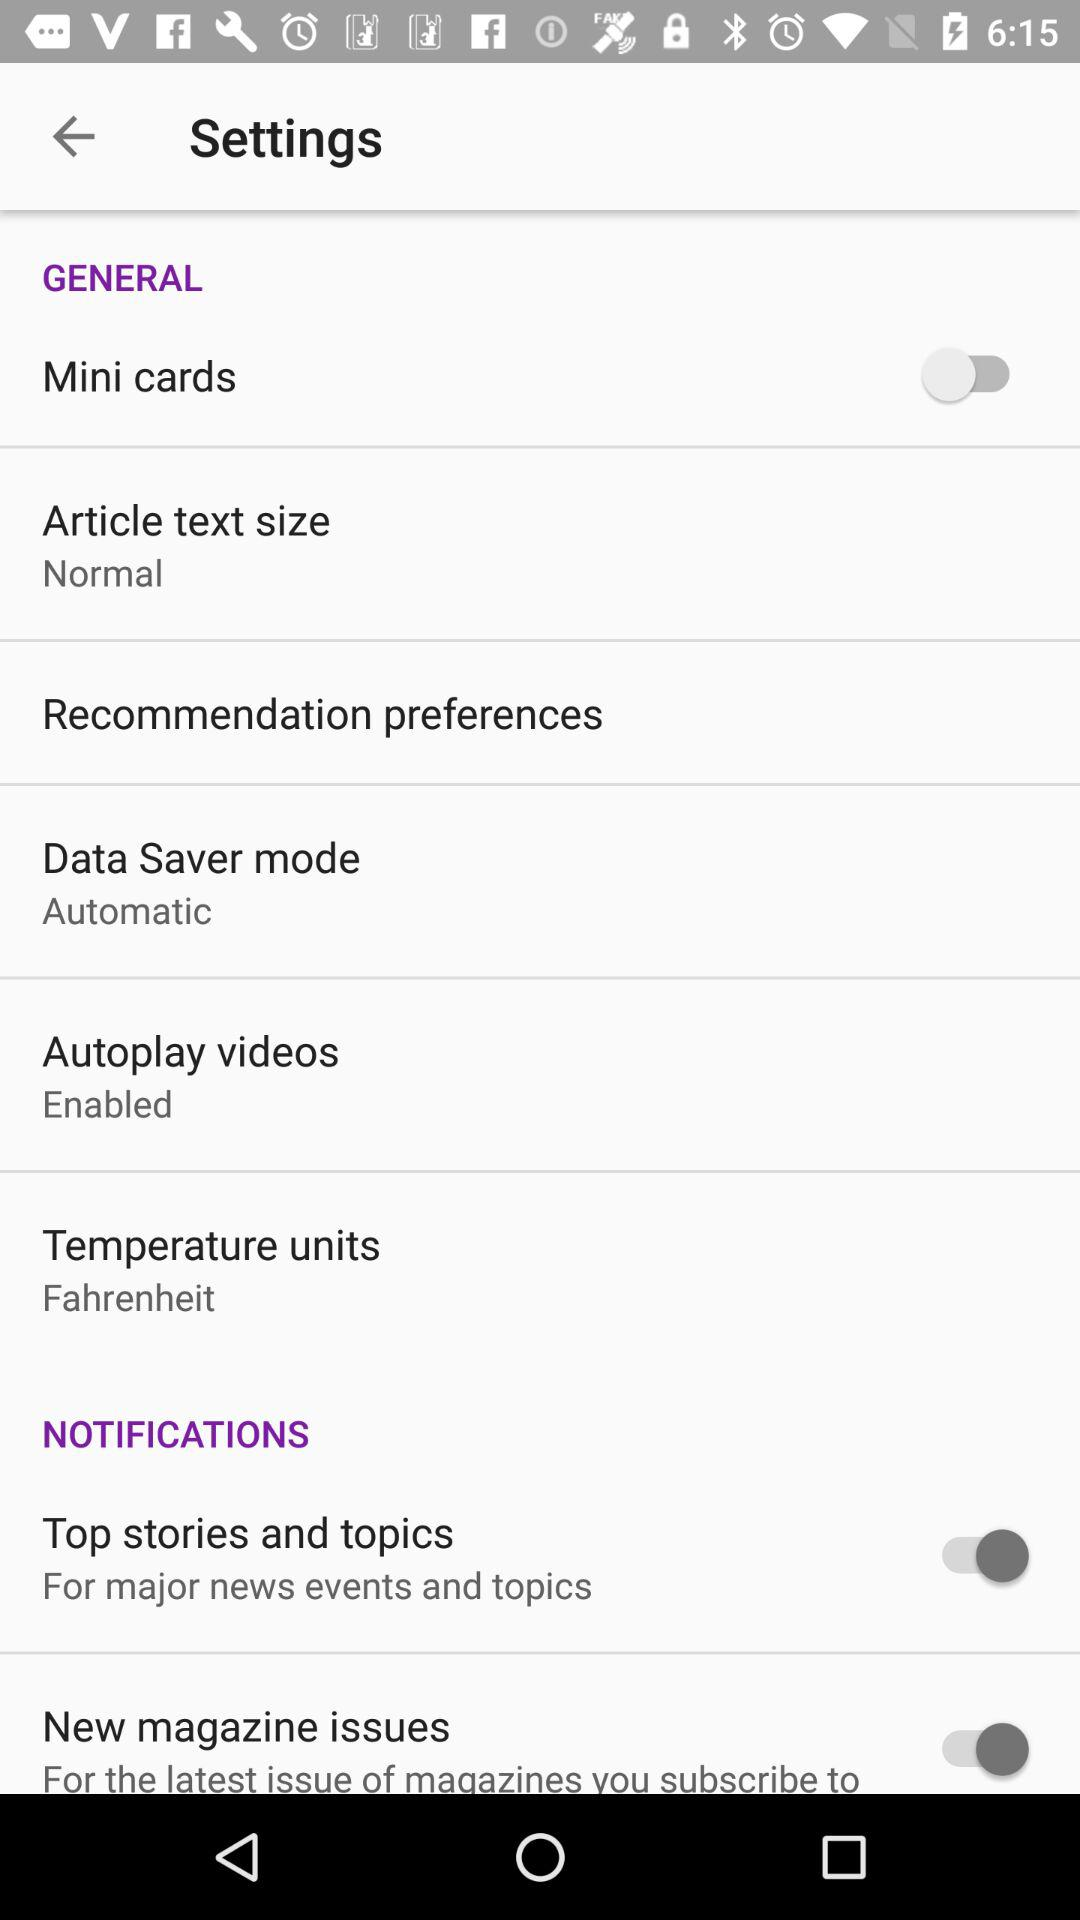How big is the normal text size in points?
When the provided information is insufficient, respond with <no answer>. <no answer> 